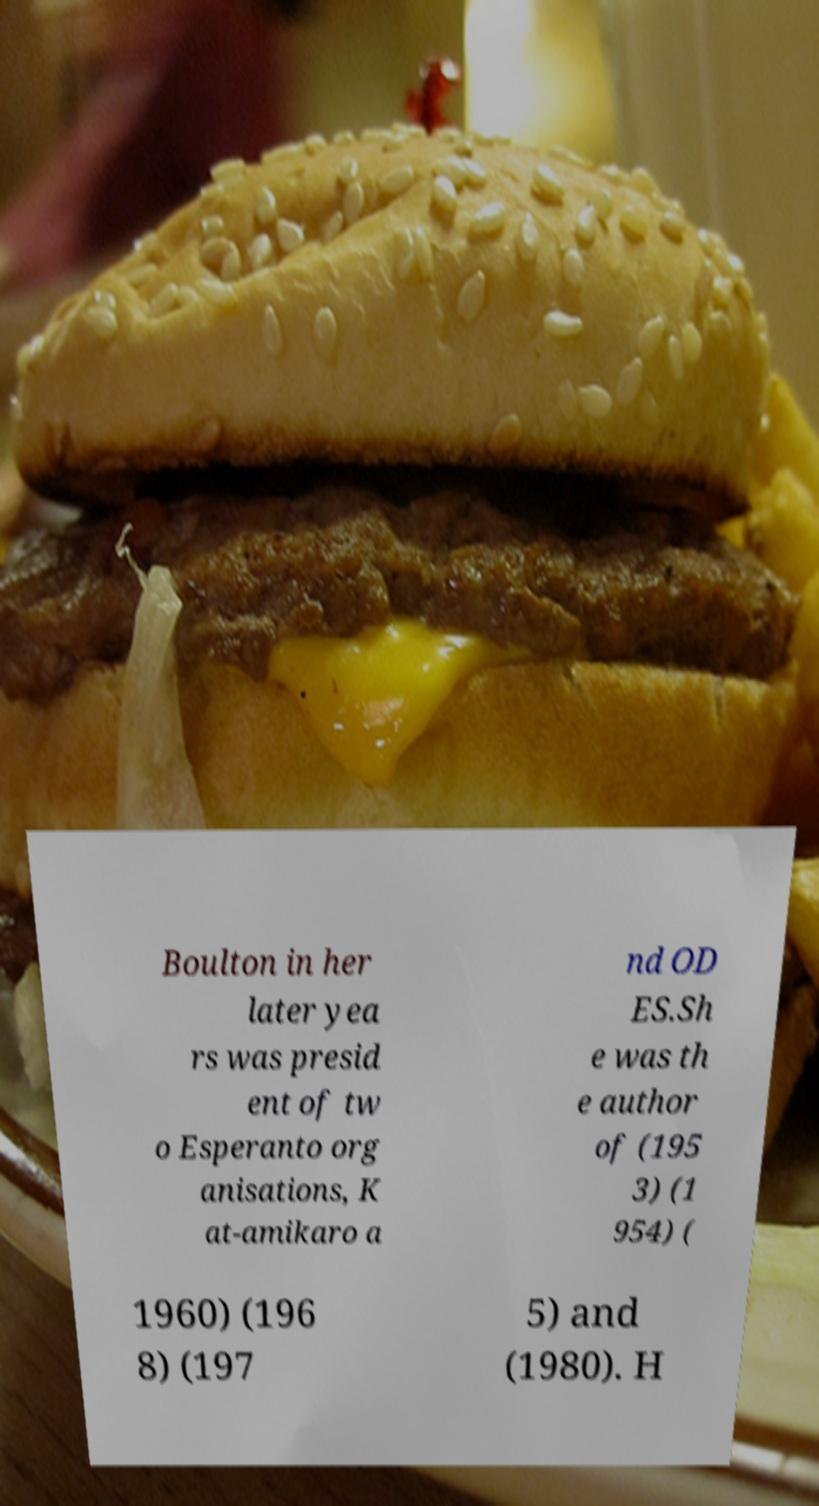I need the written content from this picture converted into text. Can you do that? Boulton in her later yea rs was presid ent of tw o Esperanto org anisations, K at-amikaro a nd OD ES.Sh e was th e author of (195 3) (1 954) ( 1960) (196 8) (197 5) and (1980). H 